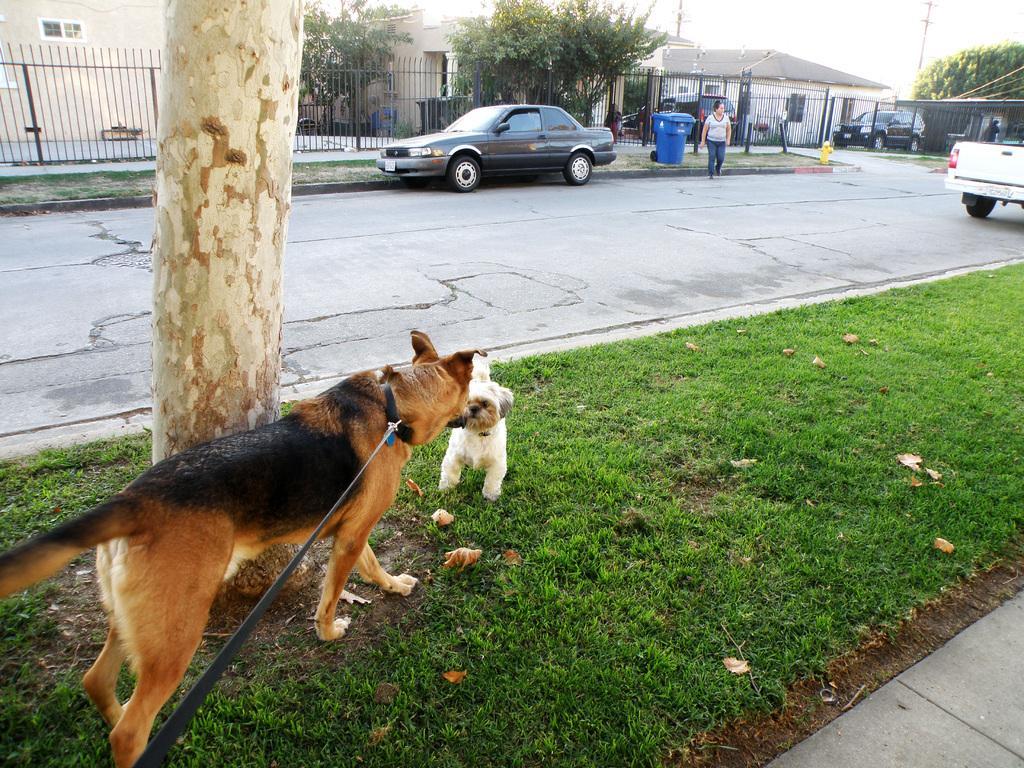Can you describe this image briefly? In this image I can see two dogs visible in front of trunk of tree on grass , in the middle I can see a road , on road I can see person , blue color container ,vehicles and fence and houses and trees , in front houses I can see vehicles visible in the middle ,at the top I can see the sky. 